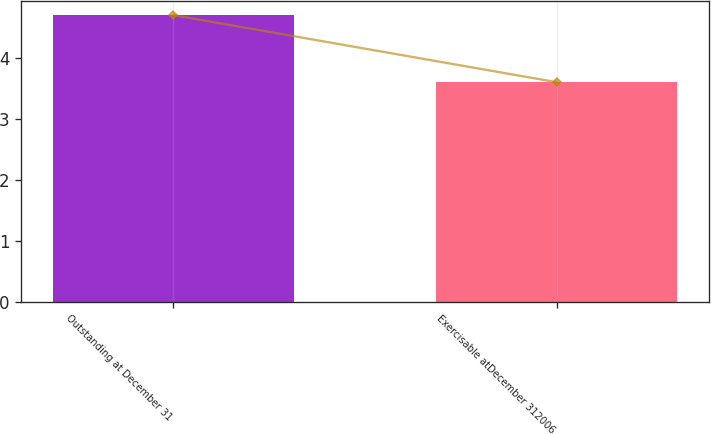<chart> <loc_0><loc_0><loc_500><loc_500><bar_chart><fcel>Outstanding at December 31<fcel>Exercisable atDecember 312006<nl><fcel>4.7<fcel>3.6<nl></chart> 